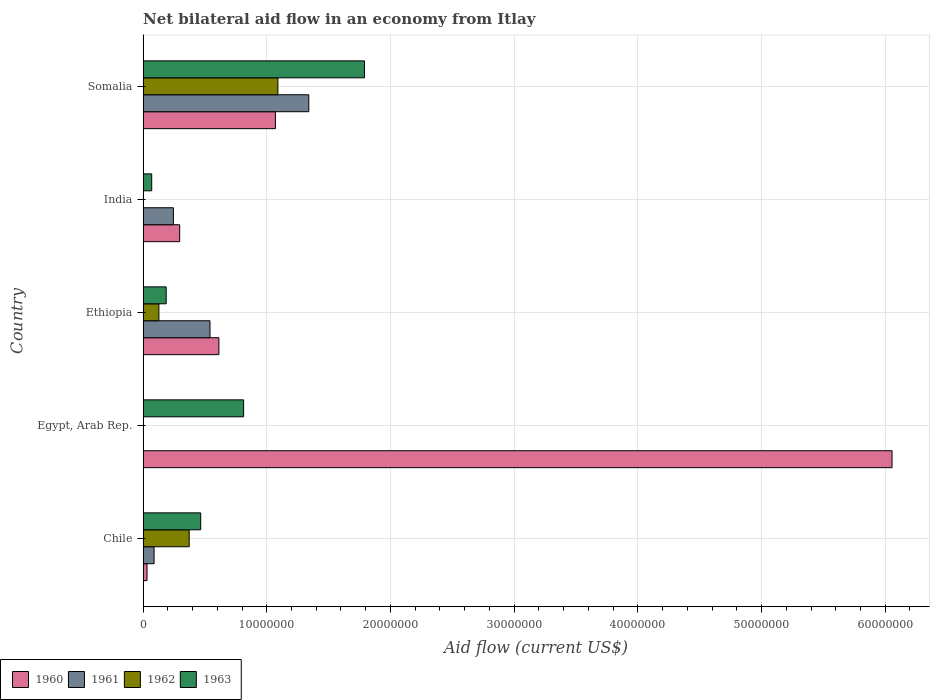How many different coloured bars are there?
Provide a short and direct response. 4. How many groups of bars are there?
Your answer should be compact. 5. How many bars are there on the 1st tick from the top?
Give a very brief answer. 4. What is the net bilateral aid flow in 1962 in Somalia?
Provide a short and direct response. 1.09e+07. Across all countries, what is the maximum net bilateral aid flow in 1960?
Offer a very short reply. 6.06e+07. In which country was the net bilateral aid flow in 1963 maximum?
Your answer should be very brief. Somalia. What is the total net bilateral aid flow in 1963 in the graph?
Your answer should be compact. 3.33e+07. What is the difference between the net bilateral aid flow in 1961 in Chile and that in Ethiopia?
Give a very brief answer. -4.52e+06. What is the difference between the net bilateral aid flow in 1962 in India and the net bilateral aid flow in 1961 in Somalia?
Offer a very short reply. -1.34e+07. What is the average net bilateral aid flow in 1961 per country?
Ensure brevity in your answer.  4.43e+06. What is the difference between the net bilateral aid flow in 1961 and net bilateral aid flow in 1962 in Somalia?
Keep it short and to the point. 2.50e+06. In how many countries, is the net bilateral aid flow in 1960 greater than 58000000 US$?
Keep it short and to the point. 1. What is the ratio of the net bilateral aid flow in 1961 in Chile to that in Ethiopia?
Your answer should be compact. 0.16. What is the difference between the highest and the second highest net bilateral aid flow in 1962?
Make the answer very short. 7.17e+06. What is the difference between the highest and the lowest net bilateral aid flow in 1961?
Keep it short and to the point. 1.34e+07. In how many countries, is the net bilateral aid flow in 1961 greater than the average net bilateral aid flow in 1961 taken over all countries?
Offer a very short reply. 2. Is it the case that in every country, the sum of the net bilateral aid flow in 1960 and net bilateral aid flow in 1962 is greater than the sum of net bilateral aid flow in 1961 and net bilateral aid flow in 1963?
Offer a very short reply. No. How many bars are there?
Your answer should be very brief. 17. Are the values on the major ticks of X-axis written in scientific E-notation?
Give a very brief answer. No. Does the graph contain grids?
Make the answer very short. Yes. How many legend labels are there?
Your answer should be compact. 4. What is the title of the graph?
Ensure brevity in your answer.  Net bilateral aid flow in an economy from Itlay. What is the label or title of the X-axis?
Your answer should be very brief. Aid flow (current US$). What is the Aid flow (current US$) of 1960 in Chile?
Offer a terse response. 3.20e+05. What is the Aid flow (current US$) in 1961 in Chile?
Provide a short and direct response. 8.90e+05. What is the Aid flow (current US$) in 1962 in Chile?
Ensure brevity in your answer.  3.73e+06. What is the Aid flow (current US$) of 1963 in Chile?
Your response must be concise. 4.66e+06. What is the Aid flow (current US$) in 1960 in Egypt, Arab Rep.?
Keep it short and to the point. 6.06e+07. What is the Aid flow (current US$) of 1962 in Egypt, Arab Rep.?
Your response must be concise. 0. What is the Aid flow (current US$) in 1963 in Egypt, Arab Rep.?
Ensure brevity in your answer.  8.13e+06. What is the Aid flow (current US$) of 1960 in Ethiopia?
Your answer should be very brief. 6.13e+06. What is the Aid flow (current US$) in 1961 in Ethiopia?
Provide a short and direct response. 5.41e+06. What is the Aid flow (current US$) of 1962 in Ethiopia?
Your response must be concise. 1.28e+06. What is the Aid flow (current US$) in 1963 in Ethiopia?
Make the answer very short. 1.87e+06. What is the Aid flow (current US$) in 1960 in India?
Your response must be concise. 2.96e+06. What is the Aid flow (current US$) of 1961 in India?
Offer a very short reply. 2.45e+06. What is the Aid flow (current US$) of 1962 in India?
Offer a terse response. 0. What is the Aid flow (current US$) of 1960 in Somalia?
Your response must be concise. 1.07e+07. What is the Aid flow (current US$) of 1961 in Somalia?
Offer a terse response. 1.34e+07. What is the Aid flow (current US$) in 1962 in Somalia?
Keep it short and to the point. 1.09e+07. What is the Aid flow (current US$) of 1963 in Somalia?
Provide a succinct answer. 1.79e+07. Across all countries, what is the maximum Aid flow (current US$) of 1960?
Ensure brevity in your answer.  6.06e+07. Across all countries, what is the maximum Aid flow (current US$) of 1961?
Ensure brevity in your answer.  1.34e+07. Across all countries, what is the maximum Aid flow (current US$) in 1962?
Make the answer very short. 1.09e+07. Across all countries, what is the maximum Aid flow (current US$) of 1963?
Your response must be concise. 1.79e+07. Across all countries, what is the minimum Aid flow (current US$) in 1962?
Make the answer very short. 0. Across all countries, what is the minimum Aid flow (current US$) in 1963?
Offer a terse response. 7.00e+05. What is the total Aid flow (current US$) in 1960 in the graph?
Give a very brief answer. 8.07e+07. What is the total Aid flow (current US$) in 1961 in the graph?
Make the answer very short. 2.22e+07. What is the total Aid flow (current US$) in 1962 in the graph?
Provide a succinct answer. 1.59e+07. What is the total Aid flow (current US$) in 1963 in the graph?
Your answer should be very brief. 3.33e+07. What is the difference between the Aid flow (current US$) in 1960 in Chile and that in Egypt, Arab Rep.?
Keep it short and to the point. -6.02e+07. What is the difference between the Aid flow (current US$) in 1963 in Chile and that in Egypt, Arab Rep.?
Your answer should be compact. -3.47e+06. What is the difference between the Aid flow (current US$) of 1960 in Chile and that in Ethiopia?
Keep it short and to the point. -5.81e+06. What is the difference between the Aid flow (current US$) of 1961 in Chile and that in Ethiopia?
Give a very brief answer. -4.52e+06. What is the difference between the Aid flow (current US$) of 1962 in Chile and that in Ethiopia?
Your answer should be very brief. 2.45e+06. What is the difference between the Aid flow (current US$) of 1963 in Chile and that in Ethiopia?
Your response must be concise. 2.79e+06. What is the difference between the Aid flow (current US$) of 1960 in Chile and that in India?
Keep it short and to the point. -2.64e+06. What is the difference between the Aid flow (current US$) of 1961 in Chile and that in India?
Your answer should be very brief. -1.56e+06. What is the difference between the Aid flow (current US$) of 1963 in Chile and that in India?
Provide a short and direct response. 3.96e+06. What is the difference between the Aid flow (current US$) in 1960 in Chile and that in Somalia?
Offer a terse response. -1.04e+07. What is the difference between the Aid flow (current US$) in 1961 in Chile and that in Somalia?
Provide a succinct answer. -1.25e+07. What is the difference between the Aid flow (current US$) in 1962 in Chile and that in Somalia?
Provide a succinct answer. -7.17e+06. What is the difference between the Aid flow (current US$) in 1963 in Chile and that in Somalia?
Provide a short and direct response. -1.32e+07. What is the difference between the Aid flow (current US$) in 1960 in Egypt, Arab Rep. and that in Ethiopia?
Make the answer very short. 5.44e+07. What is the difference between the Aid flow (current US$) in 1963 in Egypt, Arab Rep. and that in Ethiopia?
Provide a short and direct response. 6.26e+06. What is the difference between the Aid flow (current US$) of 1960 in Egypt, Arab Rep. and that in India?
Your answer should be compact. 5.76e+07. What is the difference between the Aid flow (current US$) of 1963 in Egypt, Arab Rep. and that in India?
Your answer should be very brief. 7.43e+06. What is the difference between the Aid flow (current US$) in 1960 in Egypt, Arab Rep. and that in Somalia?
Give a very brief answer. 4.98e+07. What is the difference between the Aid flow (current US$) of 1963 in Egypt, Arab Rep. and that in Somalia?
Your answer should be very brief. -9.77e+06. What is the difference between the Aid flow (current US$) of 1960 in Ethiopia and that in India?
Give a very brief answer. 3.17e+06. What is the difference between the Aid flow (current US$) in 1961 in Ethiopia and that in India?
Your answer should be very brief. 2.96e+06. What is the difference between the Aid flow (current US$) in 1963 in Ethiopia and that in India?
Offer a terse response. 1.17e+06. What is the difference between the Aid flow (current US$) of 1960 in Ethiopia and that in Somalia?
Make the answer very short. -4.57e+06. What is the difference between the Aid flow (current US$) in 1961 in Ethiopia and that in Somalia?
Keep it short and to the point. -7.99e+06. What is the difference between the Aid flow (current US$) in 1962 in Ethiopia and that in Somalia?
Make the answer very short. -9.62e+06. What is the difference between the Aid flow (current US$) in 1963 in Ethiopia and that in Somalia?
Keep it short and to the point. -1.60e+07. What is the difference between the Aid flow (current US$) of 1960 in India and that in Somalia?
Ensure brevity in your answer.  -7.74e+06. What is the difference between the Aid flow (current US$) of 1961 in India and that in Somalia?
Your answer should be very brief. -1.10e+07. What is the difference between the Aid flow (current US$) in 1963 in India and that in Somalia?
Your answer should be very brief. -1.72e+07. What is the difference between the Aid flow (current US$) in 1960 in Chile and the Aid flow (current US$) in 1963 in Egypt, Arab Rep.?
Provide a succinct answer. -7.81e+06. What is the difference between the Aid flow (current US$) of 1961 in Chile and the Aid flow (current US$) of 1963 in Egypt, Arab Rep.?
Make the answer very short. -7.24e+06. What is the difference between the Aid flow (current US$) in 1962 in Chile and the Aid flow (current US$) in 1963 in Egypt, Arab Rep.?
Make the answer very short. -4.40e+06. What is the difference between the Aid flow (current US$) of 1960 in Chile and the Aid flow (current US$) of 1961 in Ethiopia?
Keep it short and to the point. -5.09e+06. What is the difference between the Aid flow (current US$) in 1960 in Chile and the Aid flow (current US$) in 1962 in Ethiopia?
Provide a succinct answer. -9.60e+05. What is the difference between the Aid flow (current US$) in 1960 in Chile and the Aid flow (current US$) in 1963 in Ethiopia?
Your answer should be compact. -1.55e+06. What is the difference between the Aid flow (current US$) of 1961 in Chile and the Aid flow (current US$) of 1962 in Ethiopia?
Your response must be concise. -3.90e+05. What is the difference between the Aid flow (current US$) of 1961 in Chile and the Aid flow (current US$) of 1963 in Ethiopia?
Your response must be concise. -9.80e+05. What is the difference between the Aid flow (current US$) of 1962 in Chile and the Aid flow (current US$) of 1963 in Ethiopia?
Your answer should be compact. 1.86e+06. What is the difference between the Aid flow (current US$) in 1960 in Chile and the Aid flow (current US$) in 1961 in India?
Offer a very short reply. -2.13e+06. What is the difference between the Aid flow (current US$) of 1960 in Chile and the Aid flow (current US$) of 1963 in India?
Ensure brevity in your answer.  -3.80e+05. What is the difference between the Aid flow (current US$) in 1962 in Chile and the Aid flow (current US$) in 1963 in India?
Make the answer very short. 3.03e+06. What is the difference between the Aid flow (current US$) of 1960 in Chile and the Aid flow (current US$) of 1961 in Somalia?
Provide a succinct answer. -1.31e+07. What is the difference between the Aid flow (current US$) of 1960 in Chile and the Aid flow (current US$) of 1962 in Somalia?
Keep it short and to the point. -1.06e+07. What is the difference between the Aid flow (current US$) in 1960 in Chile and the Aid flow (current US$) in 1963 in Somalia?
Give a very brief answer. -1.76e+07. What is the difference between the Aid flow (current US$) of 1961 in Chile and the Aid flow (current US$) of 1962 in Somalia?
Your response must be concise. -1.00e+07. What is the difference between the Aid flow (current US$) in 1961 in Chile and the Aid flow (current US$) in 1963 in Somalia?
Give a very brief answer. -1.70e+07. What is the difference between the Aid flow (current US$) of 1962 in Chile and the Aid flow (current US$) of 1963 in Somalia?
Your answer should be very brief. -1.42e+07. What is the difference between the Aid flow (current US$) of 1960 in Egypt, Arab Rep. and the Aid flow (current US$) of 1961 in Ethiopia?
Your answer should be compact. 5.51e+07. What is the difference between the Aid flow (current US$) in 1960 in Egypt, Arab Rep. and the Aid flow (current US$) in 1962 in Ethiopia?
Your answer should be very brief. 5.93e+07. What is the difference between the Aid flow (current US$) of 1960 in Egypt, Arab Rep. and the Aid flow (current US$) of 1963 in Ethiopia?
Your response must be concise. 5.87e+07. What is the difference between the Aid flow (current US$) of 1960 in Egypt, Arab Rep. and the Aid flow (current US$) of 1961 in India?
Offer a terse response. 5.81e+07. What is the difference between the Aid flow (current US$) in 1960 in Egypt, Arab Rep. and the Aid flow (current US$) in 1963 in India?
Your answer should be compact. 5.98e+07. What is the difference between the Aid flow (current US$) of 1960 in Egypt, Arab Rep. and the Aid flow (current US$) of 1961 in Somalia?
Ensure brevity in your answer.  4.72e+07. What is the difference between the Aid flow (current US$) in 1960 in Egypt, Arab Rep. and the Aid flow (current US$) in 1962 in Somalia?
Ensure brevity in your answer.  4.96e+07. What is the difference between the Aid flow (current US$) of 1960 in Egypt, Arab Rep. and the Aid flow (current US$) of 1963 in Somalia?
Offer a terse response. 4.26e+07. What is the difference between the Aid flow (current US$) of 1960 in Ethiopia and the Aid flow (current US$) of 1961 in India?
Your answer should be compact. 3.68e+06. What is the difference between the Aid flow (current US$) in 1960 in Ethiopia and the Aid flow (current US$) in 1963 in India?
Provide a short and direct response. 5.43e+06. What is the difference between the Aid flow (current US$) of 1961 in Ethiopia and the Aid flow (current US$) of 1963 in India?
Keep it short and to the point. 4.71e+06. What is the difference between the Aid flow (current US$) in 1962 in Ethiopia and the Aid flow (current US$) in 1963 in India?
Give a very brief answer. 5.80e+05. What is the difference between the Aid flow (current US$) in 1960 in Ethiopia and the Aid flow (current US$) in 1961 in Somalia?
Make the answer very short. -7.27e+06. What is the difference between the Aid flow (current US$) of 1960 in Ethiopia and the Aid flow (current US$) of 1962 in Somalia?
Keep it short and to the point. -4.77e+06. What is the difference between the Aid flow (current US$) of 1960 in Ethiopia and the Aid flow (current US$) of 1963 in Somalia?
Offer a very short reply. -1.18e+07. What is the difference between the Aid flow (current US$) in 1961 in Ethiopia and the Aid flow (current US$) in 1962 in Somalia?
Give a very brief answer. -5.49e+06. What is the difference between the Aid flow (current US$) in 1961 in Ethiopia and the Aid flow (current US$) in 1963 in Somalia?
Your answer should be very brief. -1.25e+07. What is the difference between the Aid flow (current US$) of 1962 in Ethiopia and the Aid flow (current US$) of 1963 in Somalia?
Your answer should be compact. -1.66e+07. What is the difference between the Aid flow (current US$) of 1960 in India and the Aid flow (current US$) of 1961 in Somalia?
Your answer should be very brief. -1.04e+07. What is the difference between the Aid flow (current US$) in 1960 in India and the Aid flow (current US$) in 1962 in Somalia?
Your answer should be very brief. -7.94e+06. What is the difference between the Aid flow (current US$) of 1960 in India and the Aid flow (current US$) of 1963 in Somalia?
Provide a short and direct response. -1.49e+07. What is the difference between the Aid flow (current US$) of 1961 in India and the Aid flow (current US$) of 1962 in Somalia?
Offer a terse response. -8.45e+06. What is the difference between the Aid flow (current US$) in 1961 in India and the Aid flow (current US$) in 1963 in Somalia?
Ensure brevity in your answer.  -1.54e+07. What is the average Aid flow (current US$) of 1960 per country?
Provide a succinct answer. 1.61e+07. What is the average Aid flow (current US$) in 1961 per country?
Offer a terse response. 4.43e+06. What is the average Aid flow (current US$) of 1962 per country?
Your answer should be very brief. 3.18e+06. What is the average Aid flow (current US$) in 1963 per country?
Your response must be concise. 6.65e+06. What is the difference between the Aid flow (current US$) in 1960 and Aid flow (current US$) in 1961 in Chile?
Give a very brief answer. -5.70e+05. What is the difference between the Aid flow (current US$) in 1960 and Aid flow (current US$) in 1962 in Chile?
Provide a short and direct response. -3.41e+06. What is the difference between the Aid flow (current US$) of 1960 and Aid flow (current US$) of 1963 in Chile?
Your answer should be very brief. -4.34e+06. What is the difference between the Aid flow (current US$) in 1961 and Aid flow (current US$) in 1962 in Chile?
Offer a very short reply. -2.84e+06. What is the difference between the Aid flow (current US$) in 1961 and Aid flow (current US$) in 1963 in Chile?
Offer a terse response. -3.77e+06. What is the difference between the Aid flow (current US$) in 1962 and Aid flow (current US$) in 1963 in Chile?
Make the answer very short. -9.30e+05. What is the difference between the Aid flow (current US$) in 1960 and Aid flow (current US$) in 1963 in Egypt, Arab Rep.?
Your answer should be very brief. 5.24e+07. What is the difference between the Aid flow (current US$) of 1960 and Aid flow (current US$) of 1961 in Ethiopia?
Your answer should be compact. 7.20e+05. What is the difference between the Aid flow (current US$) of 1960 and Aid flow (current US$) of 1962 in Ethiopia?
Ensure brevity in your answer.  4.85e+06. What is the difference between the Aid flow (current US$) in 1960 and Aid flow (current US$) in 1963 in Ethiopia?
Your answer should be compact. 4.26e+06. What is the difference between the Aid flow (current US$) of 1961 and Aid flow (current US$) of 1962 in Ethiopia?
Ensure brevity in your answer.  4.13e+06. What is the difference between the Aid flow (current US$) in 1961 and Aid flow (current US$) in 1963 in Ethiopia?
Give a very brief answer. 3.54e+06. What is the difference between the Aid flow (current US$) of 1962 and Aid flow (current US$) of 1963 in Ethiopia?
Provide a succinct answer. -5.90e+05. What is the difference between the Aid flow (current US$) of 1960 and Aid flow (current US$) of 1961 in India?
Keep it short and to the point. 5.10e+05. What is the difference between the Aid flow (current US$) of 1960 and Aid flow (current US$) of 1963 in India?
Your answer should be very brief. 2.26e+06. What is the difference between the Aid flow (current US$) of 1961 and Aid flow (current US$) of 1963 in India?
Give a very brief answer. 1.75e+06. What is the difference between the Aid flow (current US$) of 1960 and Aid flow (current US$) of 1961 in Somalia?
Give a very brief answer. -2.70e+06. What is the difference between the Aid flow (current US$) of 1960 and Aid flow (current US$) of 1962 in Somalia?
Keep it short and to the point. -2.00e+05. What is the difference between the Aid flow (current US$) in 1960 and Aid flow (current US$) in 1963 in Somalia?
Provide a succinct answer. -7.20e+06. What is the difference between the Aid flow (current US$) in 1961 and Aid flow (current US$) in 1962 in Somalia?
Ensure brevity in your answer.  2.50e+06. What is the difference between the Aid flow (current US$) of 1961 and Aid flow (current US$) of 1963 in Somalia?
Keep it short and to the point. -4.50e+06. What is the difference between the Aid flow (current US$) in 1962 and Aid flow (current US$) in 1963 in Somalia?
Provide a succinct answer. -7.00e+06. What is the ratio of the Aid flow (current US$) of 1960 in Chile to that in Egypt, Arab Rep.?
Provide a succinct answer. 0.01. What is the ratio of the Aid flow (current US$) of 1963 in Chile to that in Egypt, Arab Rep.?
Your answer should be compact. 0.57. What is the ratio of the Aid flow (current US$) of 1960 in Chile to that in Ethiopia?
Give a very brief answer. 0.05. What is the ratio of the Aid flow (current US$) in 1961 in Chile to that in Ethiopia?
Offer a very short reply. 0.16. What is the ratio of the Aid flow (current US$) in 1962 in Chile to that in Ethiopia?
Offer a terse response. 2.91. What is the ratio of the Aid flow (current US$) of 1963 in Chile to that in Ethiopia?
Ensure brevity in your answer.  2.49. What is the ratio of the Aid flow (current US$) of 1960 in Chile to that in India?
Offer a very short reply. 0.11. What is the ratio of the Aid flow (current US$) in 1961 in Chile to that in India?
Offer a terse response. 0.36. What is the ratio of the Aid flow (current US$) in 1963 in Chile to that in India?
Give a very brief answer. 6.66. What is the ratio of the Aid flow (current US$) in 1960 in Chile to that in Somalia?
Ensure brevity in your answer.  0.03. What is the ratio of the Aid flow (current US$) of 1961 in Chile to that in Somalia?
Keep it short and to the point. 0.07. What is the ratio of the Aid flow (current US$) of 1962 in Chile to that in Somalia?
Offer a very short reply. 0.34. What is the ratio of the Aid flow (current US$) of 1963 in Chile to that in Somalia?
Provide a succinct answer. 0.26. What is the ratio of the Aid flow (current US$) in 1960 in Egypt, Arab Rep. to that in Ethiopia?
Your answer should be compact. 9.88. What is the ratio of the Aid flow (current US$) in 1963 in Egypt, Arab Rep. to that in Ethiopia?
Ensure brevity in your answer.  4.35. What is the ratio of the Aid flow (current US$) of 1960 in Egypt, Arab Rep. to that in India?
Keep it short and to the point. 20.46. What is the ratio of the Aid flow (current US$) in 1963 in Egypt, Arab Rep. to that in India?
Keep it short and to the point. 11.61. What is the ratio of the Aid flow (current US$) of 1960 in Egypt, Arab Rep. to that in Somalia?
Offer a very short reply. 5.66. What is the ratio of the Aid flow (current US$) of 1963 in Egypt, Arab Rep. to that in Somalia?
Ensure brevity in your answer.  0.45. What is the ratio of the Aid flow (current US$) in 1960 in Ethiopia to that in India?
Offer a terse response. 2.07. What is the ratio of the Aid flow (current US$) in 1961 in Ethiopia to that in India?
Give a very brief answer. 2.21. What is the ratio of the Aid flow (current US$) of 1963 in Ethiopia to that in India?
Give a very brief answer. 2.67. What is the ratio of the Aid flow (current US$) in 1960 in Ethiopia to that in Somalia?
Ensure brevity in your answer.  0.57. What is the ratio of the Aid flow (current US$) in 1961 in Ethiopia to that in Somalia?
Keep it short and to the point. 0.4. What is the ratio of the Aid flow (current US$) of 1962 in Ethiopia to that in Somalia?
Provide a short and direct response. 0.12. What is the ratio of the Aid flow (current US$) of 1963 in Ethiopia to that in Somalia?
Provide a short and direct response. 0.1. What is the ratio of the Aid flow (current US$) of 1960 in India to that in Somalia?
Offer a very short reply. 0.28. What is the ratio of the Aid flow (current US$) of 1961 in India to that in Somalia?
Provide a short and direct response. 0.18. What is the ratio of the Aid flow (current US$) of 1963 in India to that in Somalia?
Make the answer very short. 0.04. What is the difference between the highest and the second highest Aid flow (current US$) of 1960?
Offer a very short reply. 4.98e+07. What is the difference between the highest and the second highest Aid flow (current US$) of 1961?
Offer a terse response. 7.99e+06. What is the difference between the highest and the second highest Aid flow (current US$) in 1962?
Provide a succinct answer. 7.17e+06. What is the difference between the highest and the second highest Aid flow (current US$) in 1963?
Give a very brief answer. 9.77e+06. What is the difference between the highest and the lowest Aid flow (current US$) of 1960?
Provide a succinct answer. 6.02e+07. What is the difference between the highest and the lowest Aid flow (current US$) in 1961?
Give a very brief answer. 1.34e+07. What is the difference between the highest and the lowest Aid flow (current US$) of 1962?
Your answer should be very brief. 1.09e+07. What is the difference between the highest and the lowest Aid flow (current US$) of 1963?
Ensure brevity in your answer.  1.72e+07. 